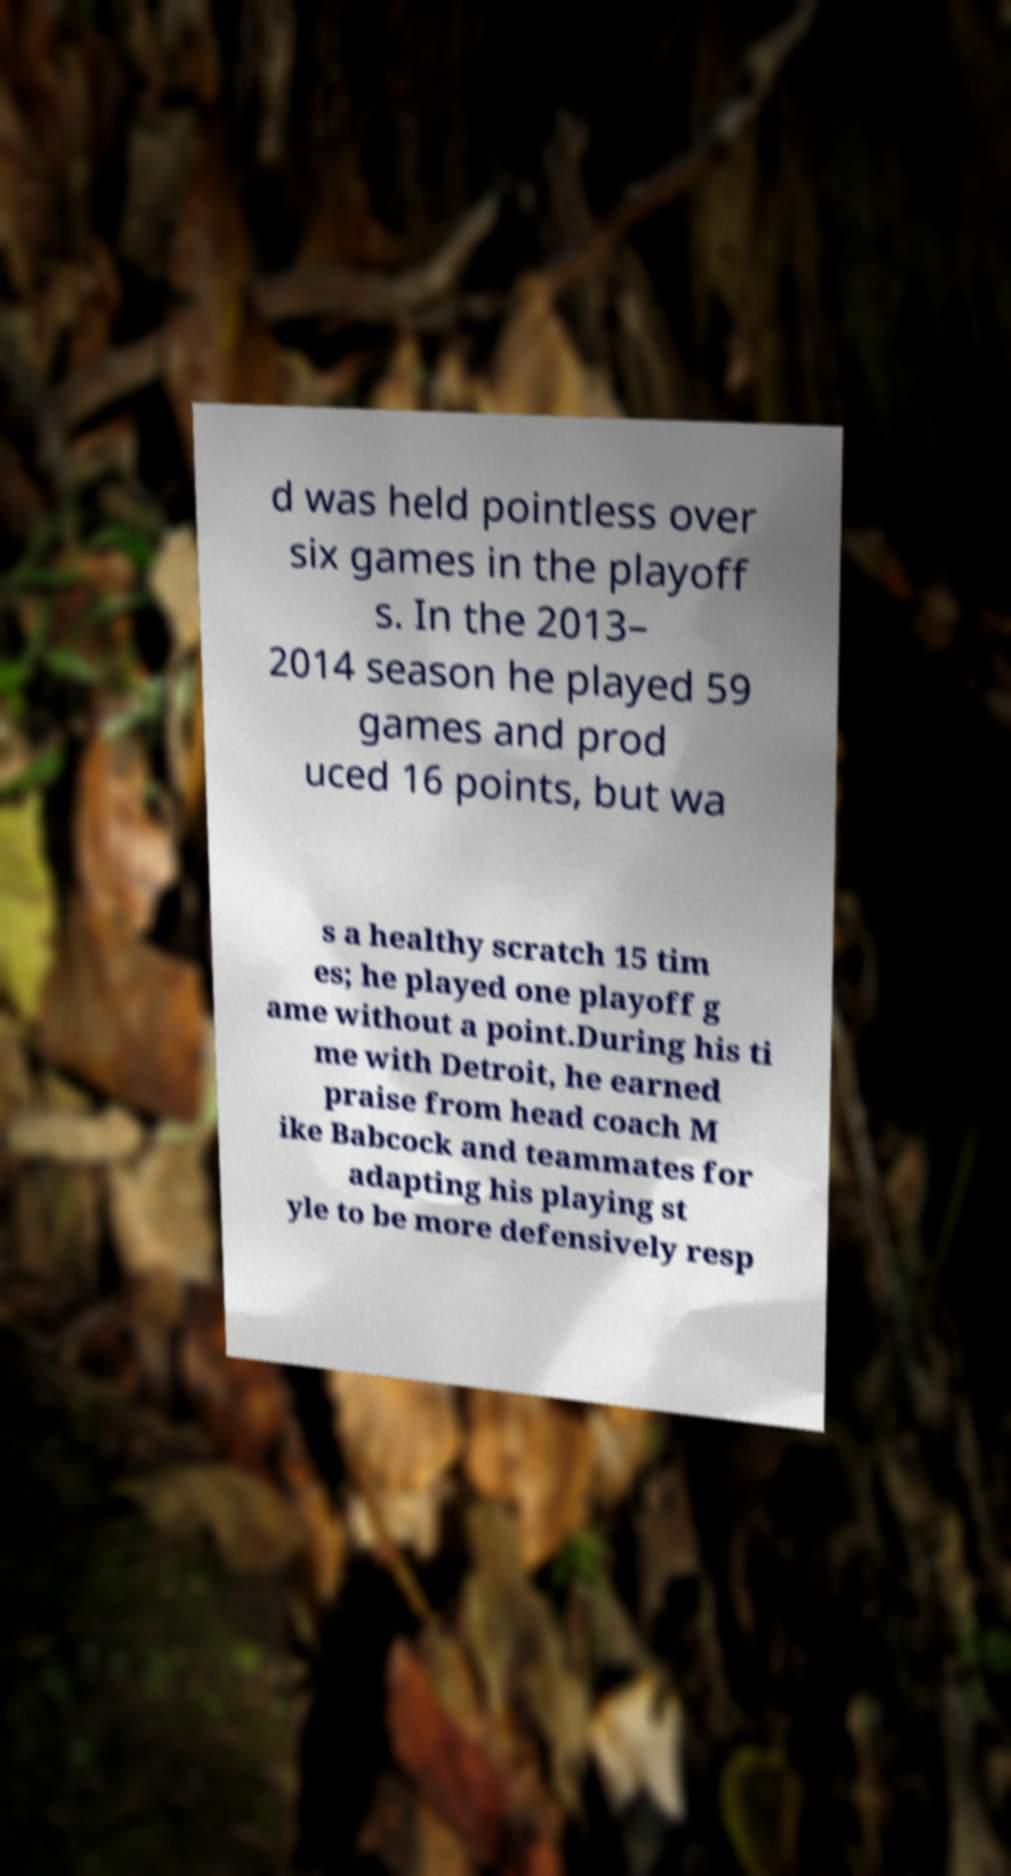Can you read and provide the text displayed in the image?This photo seems to have some interesting text. Can you extract and type it out for me? d was held pointless over six games in the playoff s. In the 2013– 2014 season he played 59 games and prod uced 16 points, but wa s a healthy scratch 15 tim es; he played one playoff g ame without a point.During his ti me with Detroit, he earned praise from head coach M ike Babcock and teammates for adapting his playing st yle to be more defensively resp 